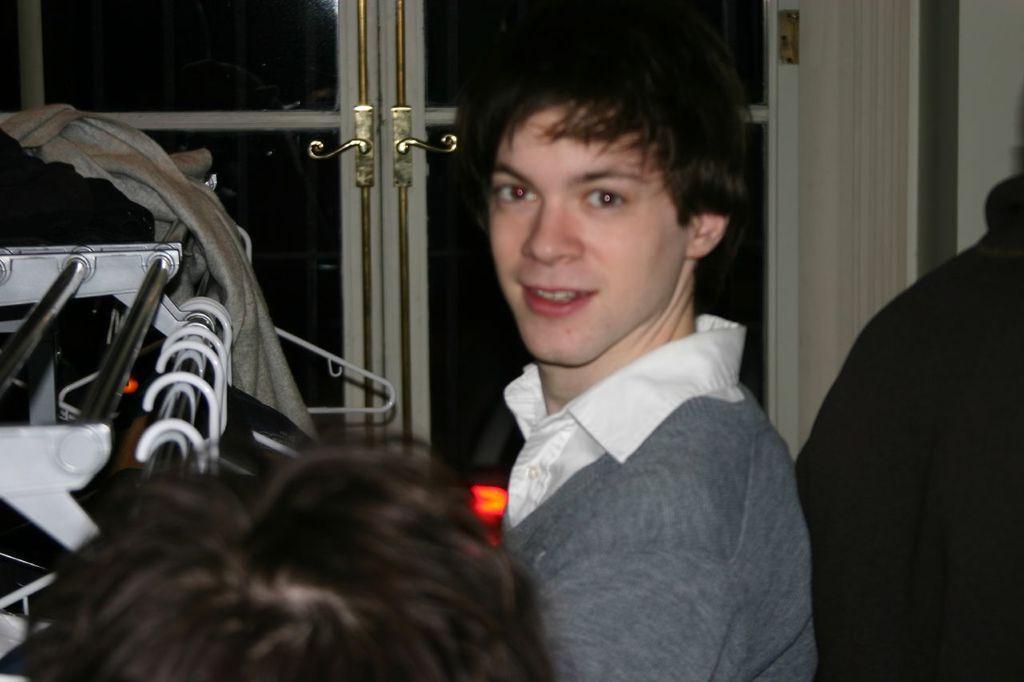Could you give a brief overview of what you see in this image? In this image there are persons. In the center there is a man smiling. On the left side there are objects and there are clothes. In the background there is a door. 